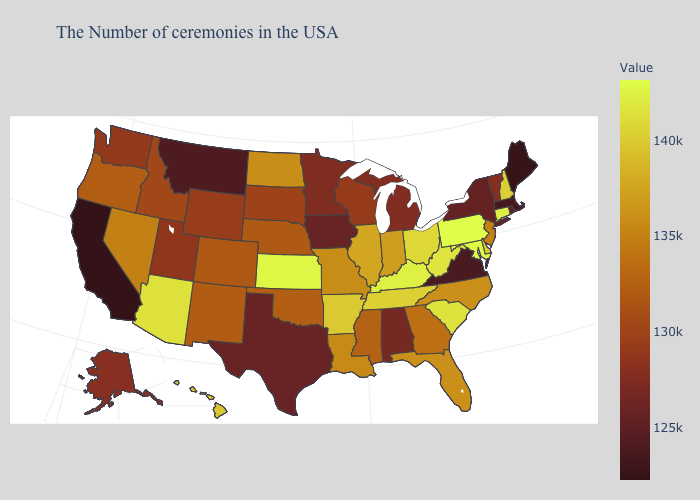Among the states that border Washington , which have the highest value?
Keep it brief. Oregon. Among the states that border Georgia , does South Carolina have the highest value?
Quick response, please. Yes. Which states have the lowest value in the Northeast?
Concise answer only. Maine. 